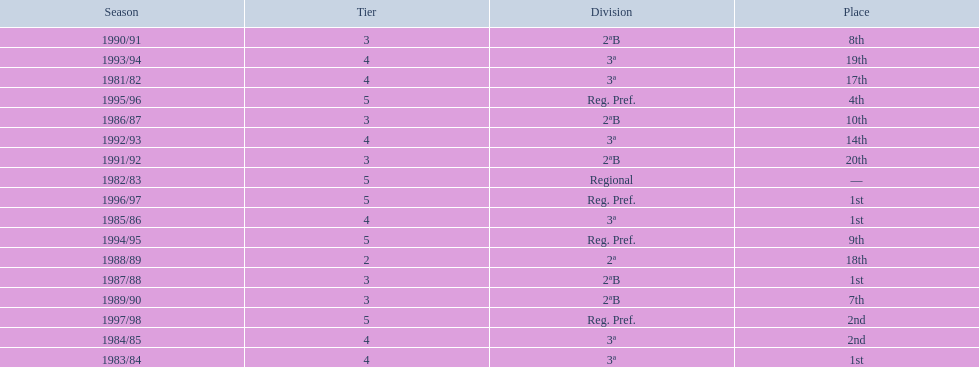Which years did the team have a season? 1981/82, 1982/83, 1983/84, 1984/85, 1985/86, 1986/87, 1987/88, 1988/89, 1989/90, 1990/91, 1991/92, 1992/93, 1993/94, 1994/95, 1995/96, 1996/97, 1997/98. Which of those years did the team place outside the top 10? 1981/82, 1988/89, 1991/92, 1992/93, 1993/94. Which of the years in which the team placed outside the top 10 did they have their worst performance? 1991/92. 